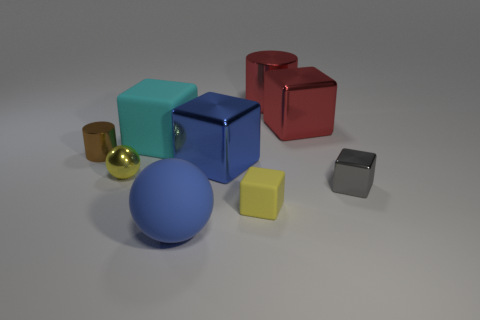Subtract all cyan blocks. How many blocks are left? 4 Subtract all red metal cubes. How many cubes are left? 4 Subtract all brown cubes. Subtract all purple cylinders. How many cubes are left? 5 Add 1 small yellow balls. How many objects exist? 10 Subtract all spheres. How many objects are left? 7 Subtract 0 brown blocks. How many objects are left? 9 Subtract all tiny metal objects. Subtract all big blocks. How many objects are left? 3 Add 8 gray metal things. How many gray metal things are left? 9 Add 6 big red shiny blocks. How many big red shiny blocks exist? 7 